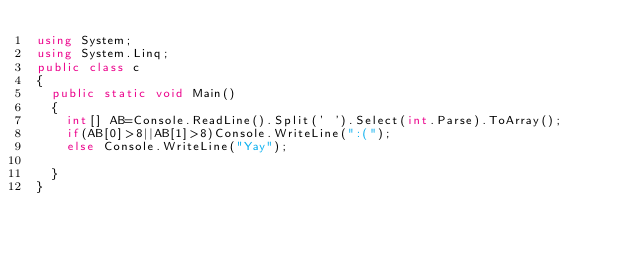<code> <loc_0><loc_0><loc_500><loc_500><_C#_>using System;
using System.Linq;
public class c
{
  public static void Main()
  {
    int[] AB=Console.ReadLine().Split(' ').Select(int.Parse).ToArray();
    if(AB[0]>8||AB[1]>8)Console.WriteLine(":(");
    else Console.WriteLine("Yay");
    
  }
}</code> 